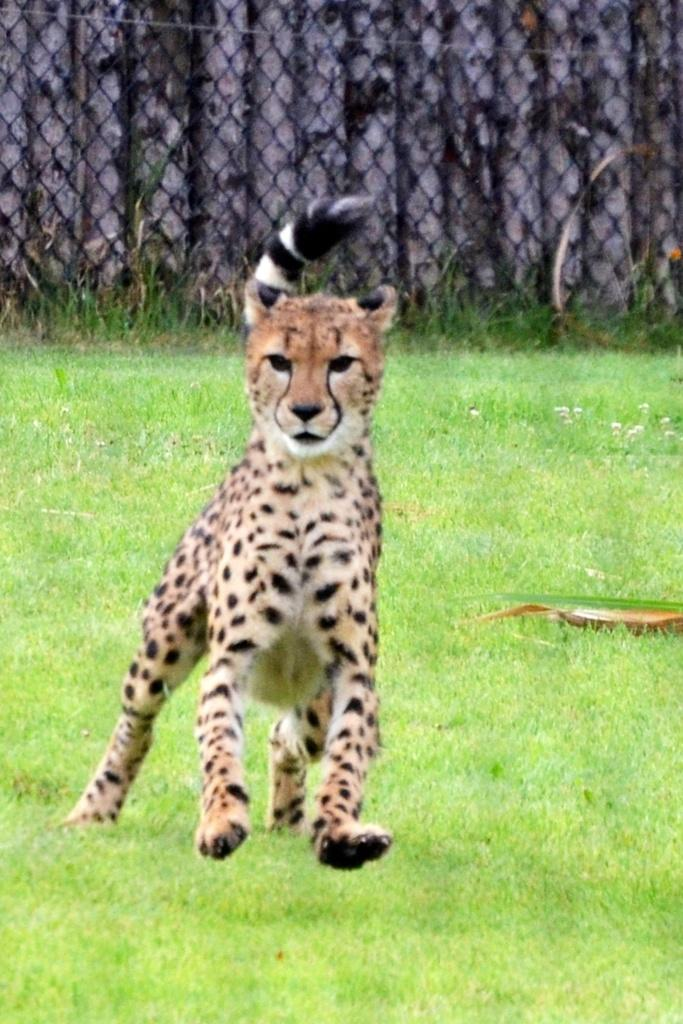What animal is the main subject of the image? There is a cheetah in the image. What is the cheetah doing in the image? The cheetah is running on the grass. What can be seen at the top of the image? There is a mesh visible at the top of the image. What type of structure might the mesh be a part of? Wooden poles are visible through the mesh, which suggests it could be part of a fence or enclosure. Can you see any fairies flying around the cheetah in the image? There are no fairies present in the image; it features a cheetah running on the grass with a mesh and wooden poles visible in the background. What type of feather can be seen on the cheetah's back in the image? There is no feather present on the cheetah's back in the image; it is a cheetah, which is a type of feline and does not have feathers. 